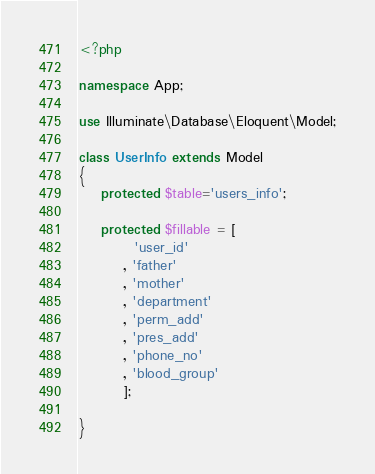Convert code to text. <code><loc_0><loc_0><loc_500><loc_500><_PHP_><?php

namespace App;

use Illuminate\Database\Eloquent\Model;

class UserInfo extends Model
{
    protected $table='users_info';

    protected $fillable = [
    	  'user_id'
    	, 'father'
    	, 'mother'
    	, 'department'
    	, 'perm_add'
    	, 'pres_add'
    	, 'phone_no'
    	, 'blood_group'
    	];

}
</code> 